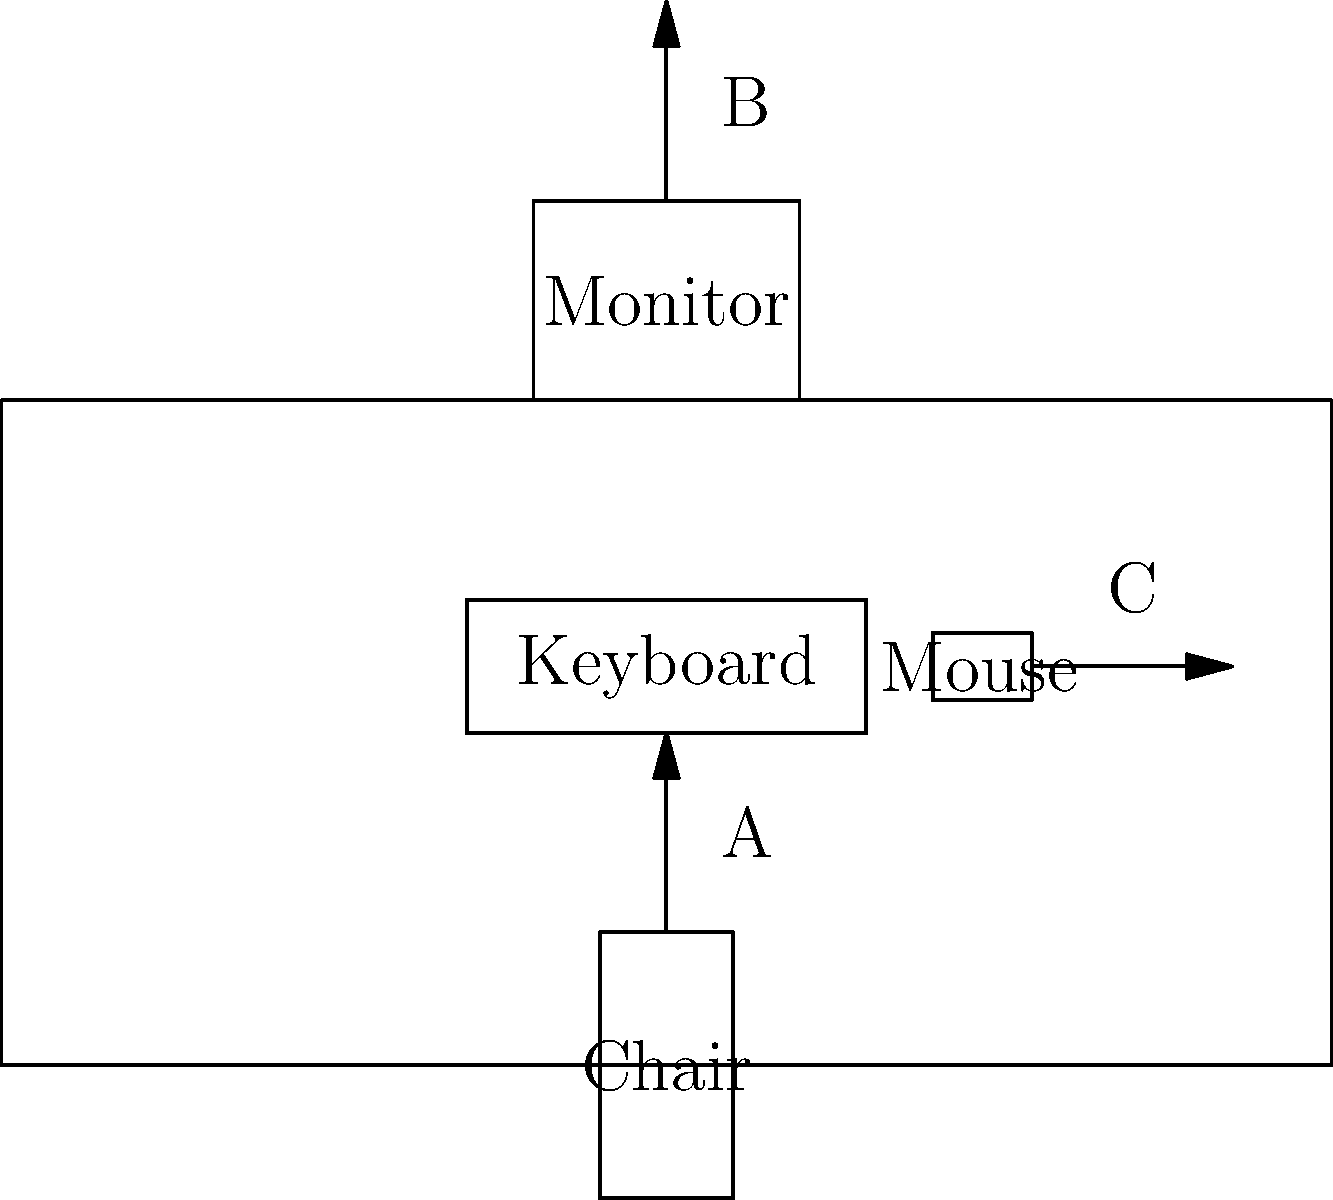In the ergonomic workstation setup shown above, which arrow (A, B, or C) represents the recommended distance between the user's eyes and the monitor screen for optimal viewing? To determine the correct arrow representing the recommended distance between the user's eyes and the monitor screen, let's consider the ergonomic principles for workstation setup:

1. Arrow A points from the chair to the keyboard, which relates to the positioning of the user's body relative to the desk and input devices.

2. Arrow B points upward from the top of the monitor, which indicates the distance between the user's eyes and the monitor screen.

3. Arrow C points to the right from the mouse, which might represent the reach distance for the input device.

The recommended distance between a user's eyes and the monitor screen is typically 20-40 inches (50-100 cm). This distance allows for comfortable viewing without straining the eyes or neck.

Arrow B is the only one that represents a measurement from the user's eye level (when seated) to the monitor screen. Therefore, it is the correct choice for indicating the optimal viewing distance.

Maintaining this proper distance helps prevent eye strain, reduces the risk of developing computer vision syndrome, and promotes better posture by encouraging users to sit at an appropriate distance from their workstation.
Answer: B 